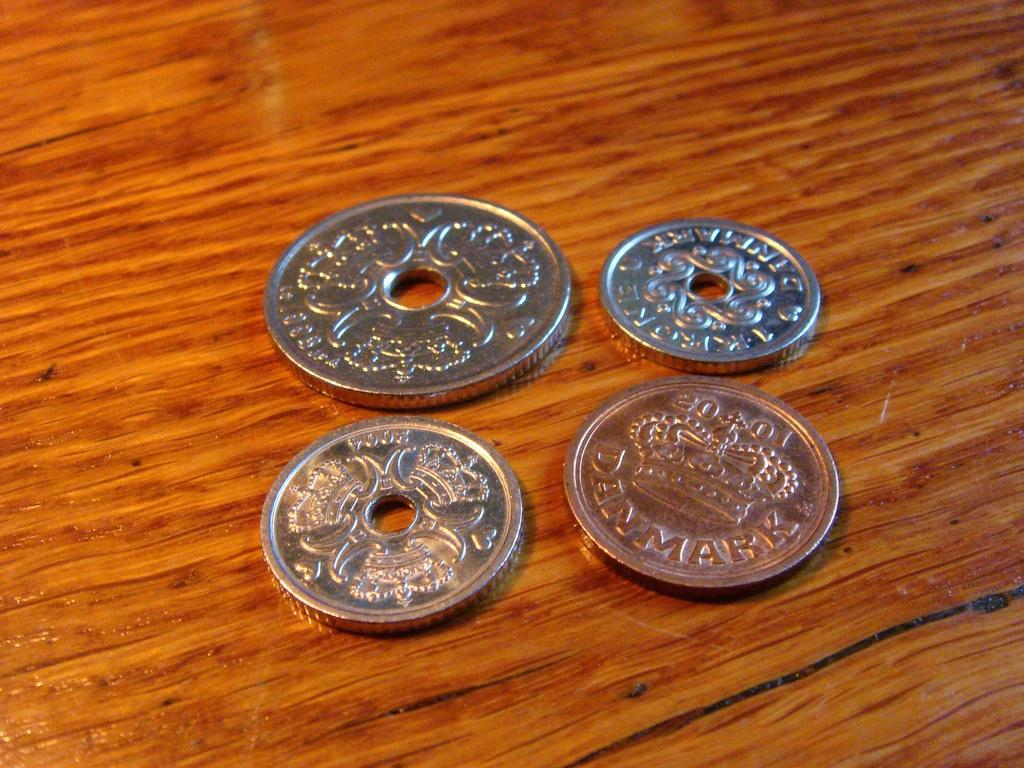<image>
Create a compact narrative representing the image presented. several coins, including at least one from denmark are laying on a table 